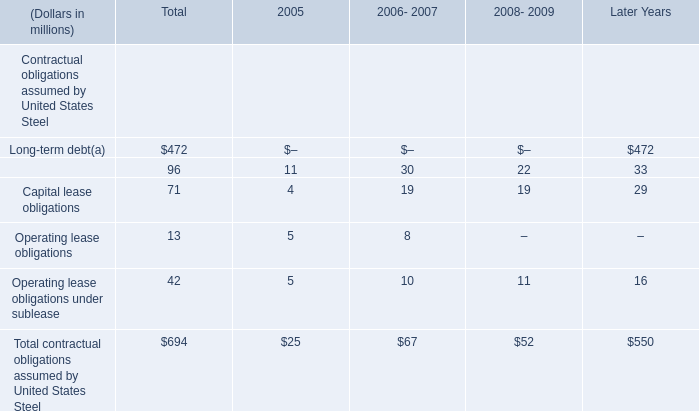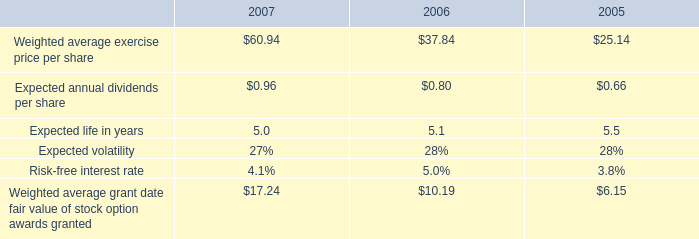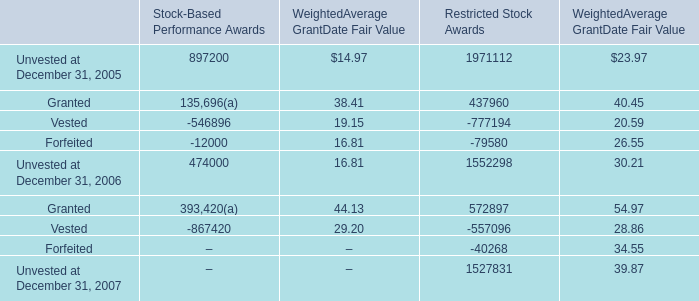by how much did the expected annual dividends per share increase from 2005 to 2007? 
Computations: ((0.96 - 0.66) / 0.66)
Answer: 0.45455. 